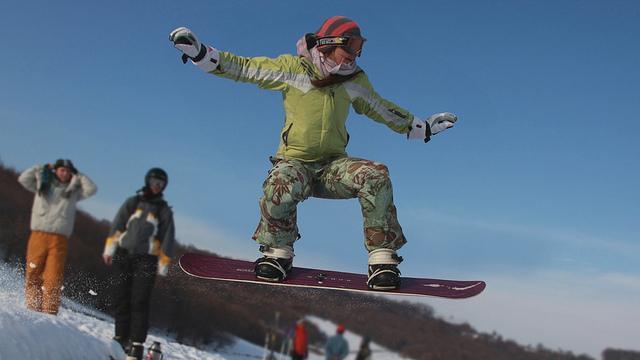Why are there straps on snowboards?
Select the accurate answer and provide justification: `Answer: choice
Rationale: srationale.`
Options: Law, support/response, style, security. Answer: support/response.
Rationale: They may also be b depending on the design, but they're primarily for a. 